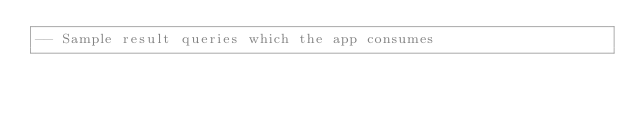<code> <loc_0><loc_0><loc_500><loc_500><_SQL_>-- Sample result queries which the app consumes
</code> 